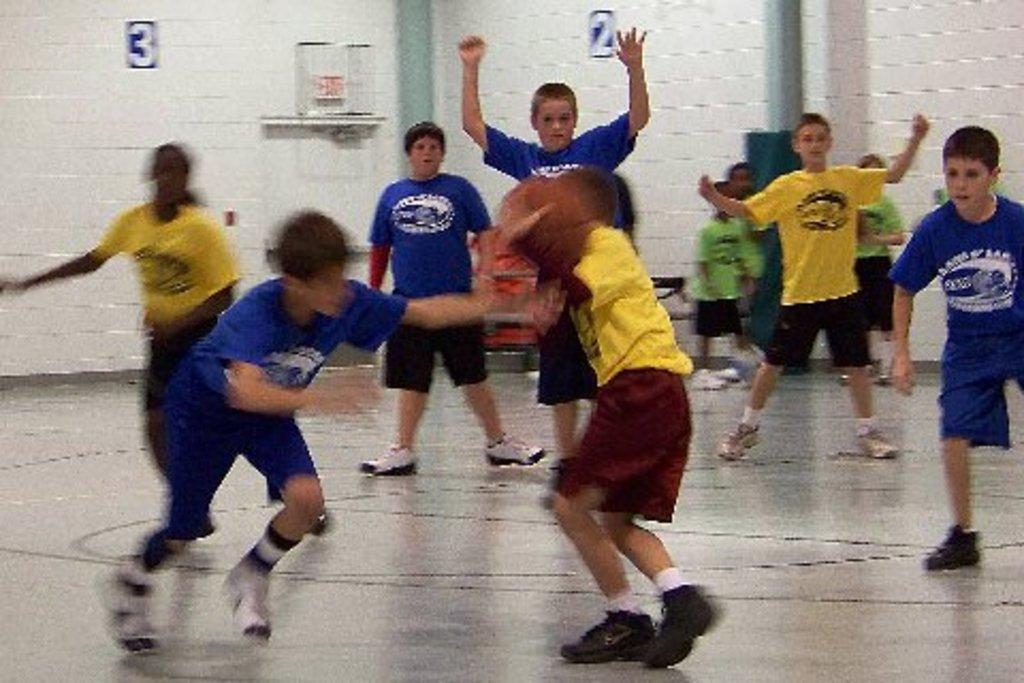Could you give a brief overview of what you see in this image? In this image there are a few boys playing on the floor. In the center there is a boy holding a ball in his hand. In the background there is a wall. There are numbers on the wall. There are a few children standing at the wall. 